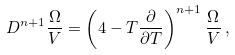Convert formula to latex. <formula><loc_0><loc_0><loc_500><loc_500>D ^ { n + 1 } \frac { \Omega } { V } = \left ( 4 - T \frac { \partial } { \partial T } \right ) ^ { n + 1 } \frac { \Omega } { V } \, ,</formula> 